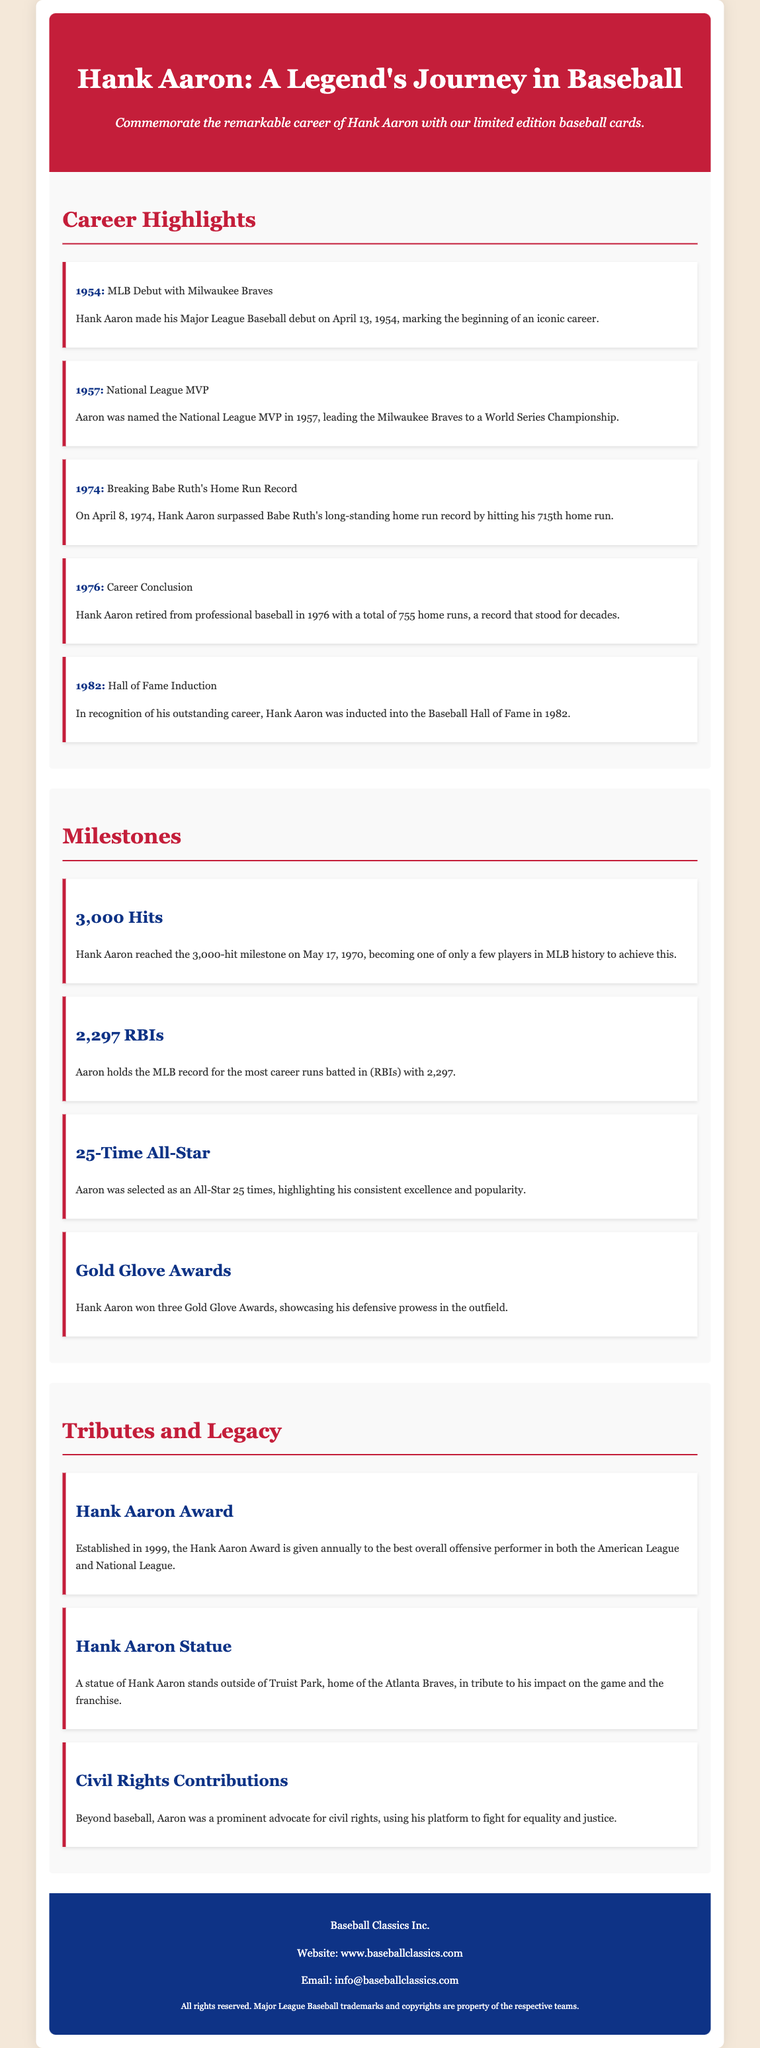What year did Hank Aaron make his MLB debut? The document states that Hank Aaron made his MLB debut on April 13, 1954.
Answer: 1954 Which award did Hank Aaron receive in 1957? The document mentions that he was named the National League MVP in 1957.
Answer: National League MVP How many home runs did Hank Aaron finish his career with? The document notes that Aaron retired with a total of 755 home runs.
Answer: 755 What significant milestone did Hank Aaron achieve on May 17, 1970? The document indicates that he reached the 3,000-hit milestone on that date.
Answer: 3,000 hits How many times was Hank Aaron selected as an All-Star? The document states that he was selected as an All-Star 25 times.
Answer: 25 times What is the name of the award established in 1999 in honor of Hank Aaron? The document highlights the Hank Aaron Award given to the best offensive performer.
Answer: Hank Aaron Award What notable statue is located outside Truist Park? The document mentions that a statue of Hank Aaron stands outside of Truist Park.
Answer: Hank Aaron statue In what year was Hank Aaron inducted into the Hall of Fame? The document states that he was inducted in 1982.
Answer: 1982 What milestone reflects Hank Aaron's record for most career RBIs? The document states that he holds the record for 2,297 RBIs.
Answer: 2,297 RBIs 